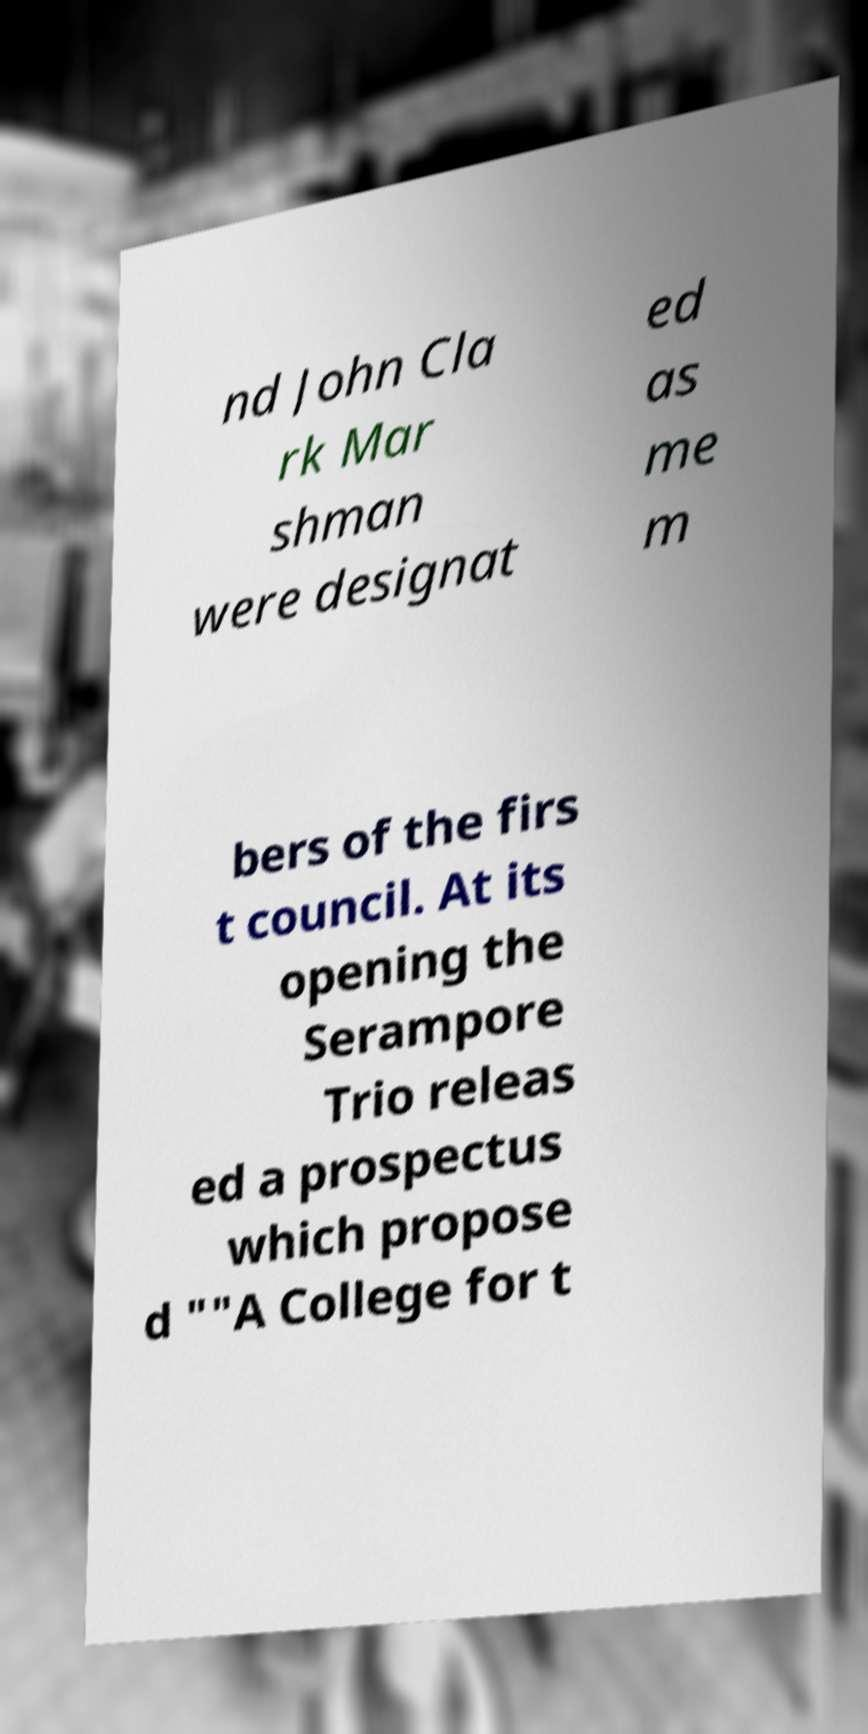For documentation purposes, I need the text within this image transcribed. Could you provide that? nd John Cla rk Mar shman were designat ed as me m bers of the firs t council. At its opening the Serampore Trio releas ed a prospectus which propose d ""A College for t 